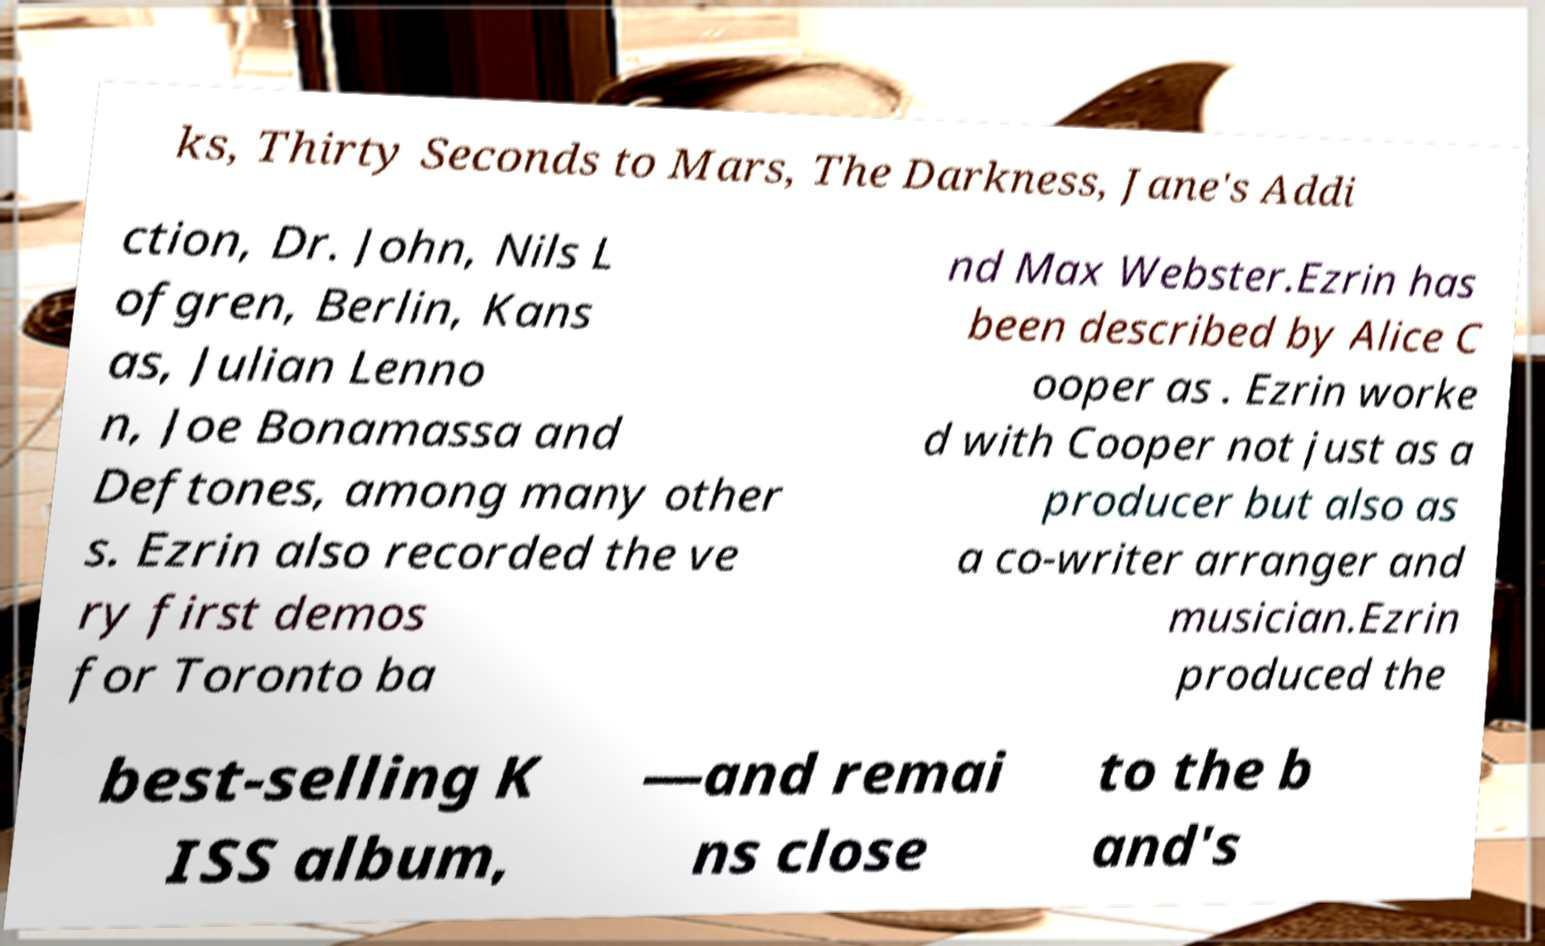Please identify and transcribe the text found in this image. ks, Thirty Seconds to Mars, The Darkness, Jane's Addi ction, Dr. John, Nils L ofgren, Berlin, Kans as, Julian Lenno n, Joe Bonamassa and Deftones, among many other s. Ezrin also recorded the ve ry first demos for Toronto ba nd Max Webster.Ezrin has been described by Alice C ooper as . Ezrin worke d with Cooper not just as a producer but also as a co-writer arranger and musician.Ezrin produced the best-selling K ISS album, —and remai ns close to the b and's 